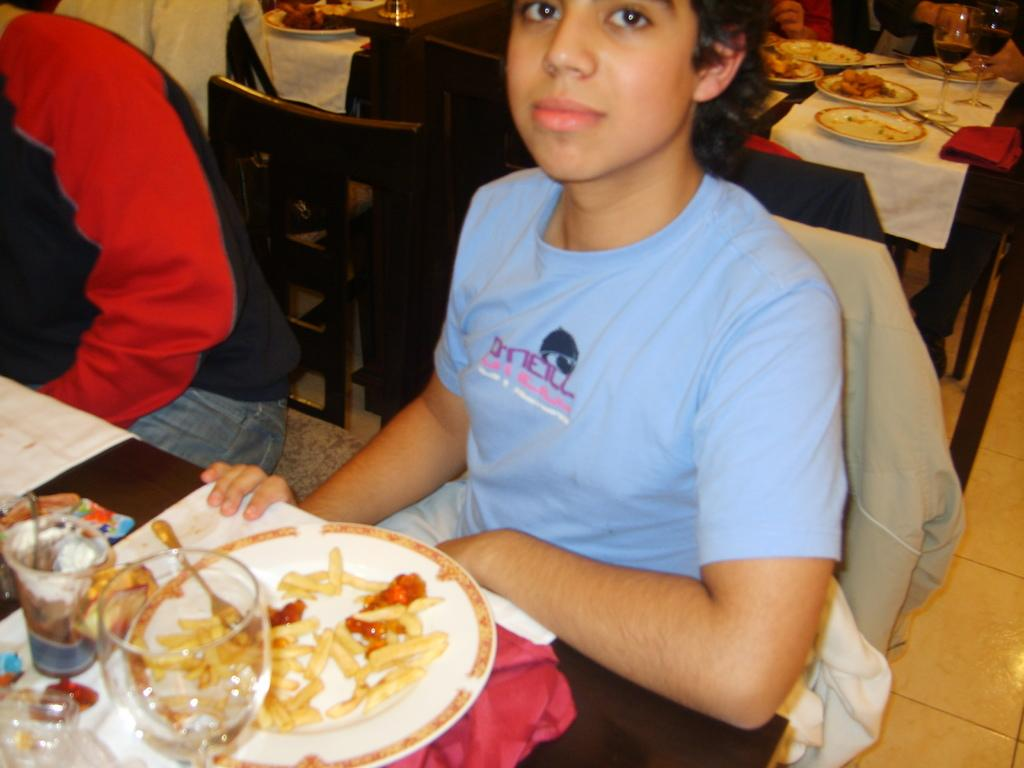What is the woman in the image doing? The woman is sitting in a chair. What can be seen on the table in the image? There is a glass, french fries, sauce, and a plate on the table. How many chairs are occupied by persons in the image? There is a group of persons sitting in chairs, but the exact number is not specified. Can you see an airplane flying over the playground in the image? There is no mention of an airplane or a playground in the image. The image features a woman sitting in a chair, a table with various items, and a group of persons sitting in chairs. 